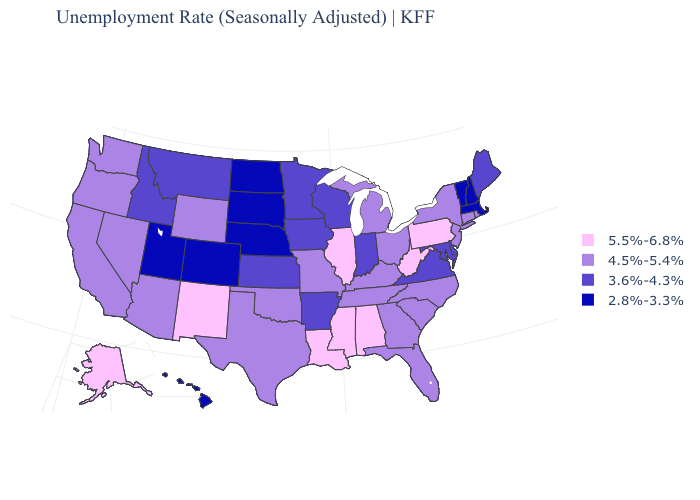Among the states that border New Jersey , which have the highest value?
Concise answer only. Pennsylvania. What is the value of Vermont?
Short answer required. 2.8%-3.3%. Does Oregon have the same value as Tennessee?
Short answer required. Yes. Name the states that have a value in the range 5.5%-6.8%?
Keep it brief. Alabama, Alaska, Illinois, Louisiana, Mississippi, New Mexico, Pennsylvania, West Virginia. Name the states that have a value in the range 4.5%-5.4%?
Keep it brief. Arizona, California, Connecticut, Florida, Georgia, Kentucky, Michigan, Missouri, Nevada, New Jersey, New York, North Carolina, Ohio, Oklahoma, Oregon, Rhode Island, South Carolina, Tennessee, Texas, Washington, Wyoming. Name the states that have a value in the range 4.5%-5.4%?
Keep it brief. Arizona, California, Connecticut, Florida, Georgia, Kentucky, Michigan, Missouri, Nevada, New Jersey, New York, North Carolina, Ohio, Oklahoma, Oregon, Rhode Island, South Carolina, Tennessee, Texas, Washington, Wyoming. What is the value of Nevada?
Short answer required. 4.5%-5.4%. What is the lowest value in the USA?
Give a very brief answer. 2.8%-3.3%. What is the value of Alaska?
Give a very brief answer. 5.5%-6.8%. Does Tennessee have the lowest value in the South?
Concise answer only. No. What is the value of Wyoming?
Be succinct. 4.5%-5.4%. Name the states that have a value in the range 4.5%-5.4%?
Concise answer only. Arizona, California, Connecticut, Florida, Georgia, Kentucky, Michigan, Missouri, Nevada, New Jersey, New York, North Carolina, Ohio, Oklahoma, Oregon, Rhode Island, South Carolina, Tennessee, Texas, Washington, Wyoming. Name the states that have a value in the range 2.8%-3.3%?
Be succinct. Colorado, Hawaii, Massachusetts, Nebraska, New Hampshire, North Dakota, South Dakota, Utah, Vermont. What is the value of Wyoming?
Quick response, please. 4.5%-5.4%. 